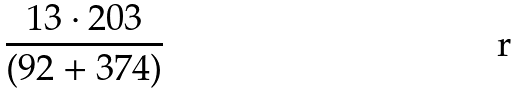Convert formula to latex. <formula><loc_0><loc_0><loc_500><loc_500>\frac { 1 3 \cdot 2 0 3 } { ( 9 2 + 3 7 4 ) }</formula> 